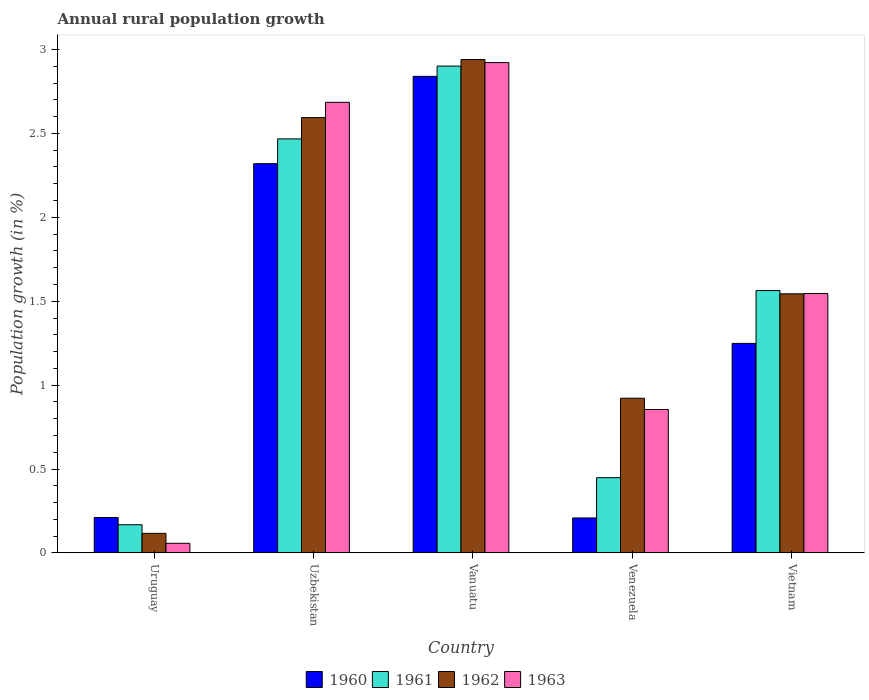How many different coloured bars are there?
Make the answer very short. 4. Are the number of bars per tick equal to the number of legend labels?
Provide a succinct answer. Yes. Are the number of bars on each tick of the X-axis equal?
Your answer should be compact. Yes. How many bars are there on the 3rd tick from the left?
Give a very brief answer. 4. How many bars are there on the 2nd tick from the right?
Your response must be concise. 4. What is the label of the 4th group of bars from the left?
Offer a very short reply. Venezuela. In how many cases, is the number of bars for a given country not equal to the number of legend labels?
Your answer should be very brief. 0. What is the percentage of rural population growth in 1962 in Uruguay?
Make the answer very short. 0.12. Across all countries, what is the maximum percentage of rural population growth in 1961?
Your response must be concise. 2.9. Across all countries, what is the minimum percentage of rural population growth in 1961?
Provide a succinct answer. 0.17. In which country was the percentage of rural population growth in 1961 maximum?
Your answer should be compact. Vanuatu. In which country was the percentage of rural population growth in 1963 minimum?
Your response must be concise. Uruguay. What is the total percentage of rural population growth in 1961 in the graph?
Ensure brevity in your answer.  7.55. What is the difference between the percentage of rural population growth in 1963 in Uruguay and that in Uzbekistan?
Provide a succinct answer. -2.63. What is the difference between the percentage of rural population growth in 1960 in Vanuatu and the percentage of rural population growth in 1963 in Uzbekistan?
Make the answer very short. 0.15. What is the average percentage of rural population growth in 1963 per country?
Offer a very short reply. 1.61. What is the difference between the percentage of rural population growth of/in 1962 and percentage of rural population growth of/in 1963 in Venezuela?
Provide a succinct answer. 0.07. In how many countries, is the percentage of rural population growth in 1962 greater than 1.6 %?
Keep it short and to the point. 2. What is the ratio of the percentage of rural population growth in 1962 in Venezuela to that in Vietnam?
Your answer should be compact. 0.6. What is the difference between the highest and the second highest percentage of rural population growth in 1961?
Make the answer very short. -1.34. What is the difference between the highest and the lowest percentage of rural population growth in 1963?
Provide a succinct answer. 2.86. In how many countries, is the percentage of rural population growth in 1963 greater than the average percentage of rural population growth in 1963 taken over all countries?
Your response must be concise. 2. Is the sum of the percentage of rural population growth in 1962 in Uruguay and Uzbekistan greater than the maximum percentage of rural population growth in 1961 across all countries?
Your answer should be compact. No. Is it the case that in every country, the sum of the percentage of rural population growth in 1961 and percentage of rural population growth in 1960 is greater than the sum of percentage of rural population growth in 1963 and percentage of rural population growth in 1962?
Offer a terse response. No. What does the 3rd bar from the left in Vanuatu represents?
Offer a terse response. 1962. What does the 2nd bar from the right in Vietnam represents?
Make the answer very short. 1962. Is it the case that in every country, the sum of the percentage of rural population growth in 1963 and percentage of rural population growth in 1962 is greater than the percentage of rural population growth in 1961?
Keep it short and to the point. Yes. How many countries are there in the graph?
Provide a short and direct response. 5. What is the difference between two consecutive major ticks on the Y-axis?
Keep it short and to the point. 0.5. Are the values on the major ticks of Y-axis written in scientific E-notation?
Ensure brevity in your answer.  No. How are the legend labels stacked?
Keep it short and to the point. Horizontal. What is the title of the graph?
Offer a terse response. Annual rural population growth. What is the label or title of the X-axis?
Your response must be concise. Country. What is the label or title of the Y-axis?
Give a very brief answer. Population growth (in %). What is the Population growth (in %) in 1960 in Uruguay?
Make the answer very short. 0.21. What is the Population growth (in %) in 1961 in Uruguay?
Give a very brief answer. 0.17. What is the Population growth (in %) of 1962 in Uruguay?
Make the answer very short. 0.12. What is the Population growth (in %) in 1963 in Uruguay?
Give a very brief answer. 0.06. What is the Population growth (in %) in 1960 in Uzbekistan?
Your response must be concise. 2.32. What is the Population growth (in %) of 1961 in Uzbekistan?
Ensure brevity in your answer.  2.47. What is the Population growth (in %) in 1962 in Uzbekistan?
Your response must be concise. 2.59. What is the Population growth (in %) in 1963 in Uzbekistan?
Your response must be concise. 2.69. What is the Population growth (in %) in 1960 in Vanuatu?
Your answer should be very brief. 2.84. What is the Population growth (in %) in 1961 in Vanuatu?
Give a very brief answer. 2.9. What is the Population growth (in %) in 1962 in Vanuatu?
Provide a short and direct response. 2.94. What is the Population growth (in %) of 1963 in Vanuatu?
Provide a short and direct response. 2.92. What is the Population growth (in %) in 1960 in Venezuela?
Give a very brief answer. 0.21. What is the Population growth (in %) in 1961 in Venezuela?
Give a very brief answer. 0.45. What is the Population growth (in %) of 1962 in Venezuela?
Provide a succinct answer. 0.92. What is the Population growth (in %) of 1963 in Venezuela?
Provide a short and direct response. 0.85. What is the Population growth (in %) of 1960 in Vietnam?
Your answer should be compact. 1.25. What is the Population growth (in %) in 1961 in Vietnam?
Give a very brief answer. 1.56. What is the Population growth (in %) in 1962 in Vietnam?
Provide a succinct answer. 1.54. What is the Population growth (in %) of 1963 in Vietnam?
Offer a very short reply. 1.55. Across all countries, what is the maximum Population growth (in %) of 1960?
Your answer should be very brief. 2.84. Across all countries, what is the maximum Population growth (in %) in 1961?
Offer a terse response. 2.9. Across all countries, what is the maximum Population growth (in %) of 1962?
Keep it short and to the point. 2.94. Across all countries, what is the maximum Population growth (in %) of 1963?
Keep it short and to the point. 2.92. Across all countries, what is the minimum Population growth (in %) in 1960?
Provide a succinct answer. 0.21. Across all countries, what is the minimum Population growth (in %) in 1961?
Offer a very short reply. 0.17. Across all countries, what is the minimum Population growth (in %) of 1962?
Give a very brief answer. 0.12. Across all countries, what is the minimum Population growth (in %) in 1963?
Give a very brief answer. 0.06. What is the total Population growth (in %) in 1960 in the graph?
Your answer should be compact. 6.83. What is the total Population growth (in %) in 1961 in the graph?
Provide a succinct answer. 7.55. What is the total Population growth (in %) in 1962 in the graph?
Make the answer very short. 8.12. What is the total Population growth (in %) in 1963 in the graph?
Give a very brief answer. 8.07. What is the difference between the Population growth (in %) in 1960 in Uruguay and that in Uzbekistan?
Make the answer very short. -2.11. What is the difference between the Population growth (in %) in 1961 in Uruguay and that in Uzbekistan?
Offer a very short reply. -2.3. What is the difference between the Population growth (in %) in 1962 in Uruguay and that in Uzbekistan?
Give a very brief answer. -2.48. What is the difference between the Population growth (in %) of 1963 in Uruguay and that in Uzbekistan?
Offer a terse response. -2.63. What is the difference between the Population growth (in %) of 1960 in Uruguay and that in Vanuatu?
Your answer should be very brief. -2.63. What is the difference between the Population growth (in %) of 1961 in Uruguay and that in Vanuatu?
Offer a terse response. -2.73. What is the difference between the Population growth (in %) in 1962 in Uruguay and that in Vanuatu?
Make the answer very short. -2.82. What is the difference between the Population growth (in %) in 1963 in Uruguay and that in Vanuatu?
Your response must be concise. -2.86. What is the difference between the Population growth (in %) in 1960 in Uruguay and that in Venezuela?
Offer a very short reply. 0. What is the difference between the Population growth (in %) in 1961 in Uruguay and that in Venezuela?
Offer a terse response. -0.28. What is the difference between the Population growth (in %) in 1962 in Uruguay and that in Venezuela?
Your answer should be compact. -0.81. What is the difference between the Population growth (in %) of 1963 in Uruguay and that in Venezuela?
Your answer should be very brief. -0.8. What is the difference between the Population growth (in %) in 1960 in Uruguay and that in Vietnam?
Provide a succinct answer. -1.04. What is the difference between the Population growth (in %) in 1961 in Uruguay and that in Vietnam?
Give a very brief answer. -1.4. What is the difference between the Population growth (in %) of 1962 in Uruguay and that in Vietnam?
Your response must be concise. -1.43. What is the difference between the Population growth (in %) of 1963 in Uruguay and that in Vietnam?
Ensure brevity in your answer.  -1.49. What is the difference between the Population growth (in %) of 1960 in Uzbekistan and that in Vanuatu?
Your response must be concise. -0.52. What is the difference between the Population growth (in %) of 1961 in Uzbekistan and that in Vanuatu?
Ensure brevity in your answer.  -0.43. What is the difference between the Population growth (in %) of 1962 in Uzbekistan and that in Vanuatu?
Give a very brief answer. -0.35. What is the difference between the Population growth (in %) of 1963 in Uzbekistan and that in Vanuatu?
Make the answer very short. -0.24. What is the difference between the Population growth (in %) in 1960 in Uzbekistan and that in Venezuela?
Your answer should be very brief. 2.11. What is the difference between the Population growth (in %) in 1961 in Uzbekistan and that in Venezuela?
Provide a succinct answer. 2.02. What is the difference between the Population growth (in %) in 1962 in Uzbekistan and that in Venezuela?
Offer a terse response. 1.67. What is the difference between the Population growth (in %) of 1963 in Uzbekistan and that in Venezuela?
Give a very brief answer. 1.83. What is the difference between the Population growth (in %) in 1960 in Uzbekistan and that in Vietnam?
Give a very brief answer. 1.07. What is the difference between the Population growth (in %) of 1961 in Uzbekistan and that in Vietnam?
Keep it short and to the point. 0.9. What is the difference between the Population growth (in %) of 1962 in Uzbekistan and that in Vietnam?
Give a very brief answer. 1.05. What is the difference between the Population growth (in %) in 1963 in Uzbekistan and that in Vietnam?
Give a very brief answer. 1.14. What is the difference between the Population growth (in %) in 1960 in Vanuatu and that in Venezuela?
Ensure brevity in your answer.  2.63. What is the difference between the Population growth (in %) of 1961 in Vanuatu and that in Venezuela?
Offer a terse response. 2.45. What is the difference between the Population growth (in %) of 1962 in Vanuatu and that in Venezuela?
Your answer should be compact. 2.02. What is the difference between the Population growth (in %) of 1963 in Vanuatu and that in Venezuela?
Make the answer very short. 2.07. What is the difference between the Population growth (in %) of 1960 in Vanuatu and that in Vietnam?
Provide a succinct answer. 1.59. What is the difference between the Population growth (in %) of 1961 in Vanuatu and that in Vietnam?
Keep it short and to the point. 1.34. What is the difference between the Population growth (in %) of 1962 in Vanuatu and that in Vietnam?
Your answer should be compact. 1.4. What is the difference between the Population growth (in %) in 1963 in Vanuatu and that in Vietnam?
Keep it short and to the point. 1.38. What is the difference between the Population growth (in %) in 1960 in Venezuela and that in Vietnam?
Provide a succinct answer. -1.04. What is the difference between the Population growth (in %) of 1961 in Venezuela and that in Vietnam?
Provide a succinct answer. -1.11. What is the difference between the Population growth (in %) in 1962 in Venezuela and that in Vietnam?
Keep it short and to the point. -0.62. What is the difference between the Population growth (in %) in 1963 in Venezuela and that in Vietnam?
Your answer should be very brief. -0.69. What is the difference between the Population growth (in %) of 1960 in Uruguay and the Population growth (in %) of 1961 in Uzbekistan?
Your response must be concise. -2.26. What is the difference between the Population growth (in %) in 1960 in Uruguay and the Population growth (in %) in 1962 in Uzbekistan?
Offer a very short reply. -2.38. What is the difference between the Population growth (in %) in 1960 in Uruguay and the Population growth (in %) in 1963 in Uzbekistan?
Offer a terse response. -2.47. What is the difference between the Population growth (in %) of 1961 in Uruguay and the Population growth (in %) of 1962 in Uzbekistan?
Provide a succinct answer. -2.43. What is the difference between the Population growth (in %) of 1961 in Uruguay and the Population growth (in %) of 1963 in Uzbekistan?
Provide a short and direct response. -2.52. What is the difference between the Population growth (in %) of 1962 in Uruguay and the Population growth (in %) of 1963 in Uzbekistan?
Your answer should be compact. -2.57. What is the difference between the Population growth (in %) in 1960 in Uruguay and the Population growth (in %) in 1961 in Vanuatu?
Provide a short and direct response. -2.69. What is the difference between the Population growth (in %) of 1960 in Uruguay and the Population growth (in %) of 1962 in Vanuatu?
Give a very brief answer. -2.73. What is the difference between the Population growth (in %) of 1960 in Uruguay and the Population growth (in %) of 1963 in Vanuatu?
Offer a terse response. -2.71. What is the difference between the Population growth (in %) in 1961 in Uruguay and the Population growth (in %) in 1962 in Vanuatu?
Offer a very short reply. -2.77. What is the difference between the Population growth (in %) of 1961 in Uruguay and the Population growth (in %) of 1963 in Vanuatu?
Ensure brevity in your answer.  -2.75. What is the difference between the Population growth (in %) of 1962 in Uruguay and the Population growth (in %) of 1963 in Vanuatu?
Offer a terse response. -2.8. What is the difference between the Population growth (in %) in 1960 in Uruguay and the Population growth (in %) in 1961 in Venezuela?
Provide a succinct answer. -0.24. What is the difference between the Population growth (in %) of 1960 in Uruguay and the Population growth (in %) of 1962 in Venezuela?
Provide a short and direct response. -0.71. What is the difference between the Population growth (in %) in 1960 in Uruguay and the Population growth (in %) in 1963 in Venezuela?
Keep it short and to the point. -0.64. What is the difference between the Population growth (in %) of 1961 in Uruguay and the Population growth (in %) of 1962 in Venezuela?
Provide a short and direct response. -0.75. What is the difference between the Population growth (in %) in 1961 in Uruguay and the Population growth (in %) in 1963 in Venezuela?
Provide a succinct answer. -0.69. What is the difference between the Population growth (in %) in 1962 in Uruguay and the Population growth (in %) in 1963 in Venezuela?
Keep it short and to the point. -0.74. What is the difference between the Population growth (in %) of 1960 in Uruguay and the Population growth (in %) of 1961 in Vietnam?
Your answer should be compact. -1.35. What is the difference between the Population growth (in %) in 1960 in Uruguay and the Population growth (in %) in 1962 in Vietnam?
Your response must be concise. -1.33. What is the difference between the Population growth (in %) of 1960 in Uruguay and the Population growth (in %) of 1963 in Vietnam?
Make the answer very short. -1.33. What is the difference between the Population growth (in %) of 1961 in Uruguay and the Population growth (in %) of 1962 in Vietnam?
Your response must be concise. -1.38. What is the difference between the Population growth (in %) of 1961 in Uruguay and the Population growth (in %) of 1963 in Vietnam?
Provide a succinct answer. -1.38. What is the difference between the Population growth (in %) in 1962 in Uruguay and the Population growth (in %) in 1963 in Vietnam?
Your response must be concise. -1.43. What is the difference between the Population growth (in %) of 1960 in Uzbekistan and the Population growth (in %) of 1961 in Vanuatu?
Keep it short and to the point. -0.58. What is the difference between the Population growth (in %) of 1960 in Uzbekistan and the Population growth (in %) of 1962 in Vanuatu?
Provide a succinct answer. -0.62. What is the difference between the Population growth (in %) in 1960 in Uzbekistan and the Population growth (in %) in 1963 in Vanuatu?
Your answer should be very brief. -0.6. What is the difference between the Population growth (in %) in 1961 in Uzbekistan and the Population growth (in %) in 1962 in Vanuatu?
Keep it short and to the point. -0.47. What is the difference between the Population growth (in %) of 1961 in Uzbekistan and the Population growth (in %) of 1963 in Vanuatu?
Ensure brevity in your answer.  -0.45. What is the difference between the Population growth (in %) in 1962 in Uzbekistan and the Population growth (in %) in 1963 in Vanuatu?
Give a very brief answer. -0.33. What is the difference between the Population growth (in %) in 1960 in Uzbekistan and the Population growth (in %) in 1961 in Venezuela?
Keep it short and to the point. 1.87. What is the difference between the Population growth (in %) in 1960 in Uzbekistan and the Population growth (in %) in 1962 in Venezuela?
Give a very brief answer. 1.4. What is the difference between the Population growth (in %) of 1960 in Uzbekistan and the Population growth (in %) of 1963 in Venezuela?
Give a very brief answer. 1.46. What is the difference between the Population growth (in %) of 1961 in Uzbekistan and the Population growth (in %) of 1962 in Venezuela?
Your answer should be very brief. 1.55. What is the difference between the Population growth (in %) of 1961 in Uzbekistan and the Population growth (in %) of 1963 in Venezuela?
Give a very brief answer. 1.61. What is the difference between the Population growth (in %) of 1962 in Uzbekistan and the Population growth (in %) of 1963 in Venezuela?
Offer a terse response. 1.74. What is the difference between the Population growth (in %) in 1960 in Uzbekistan and the Population growth (in %) in 1961 in Vietnam?
Ensure brevity in your answer.  0.76. What is the difference between the Population growth (in %) in 1960 in Uzbekistan and the Population growth (in %) in 1962 in Vietnam?
Keep it short and to the point. 0.78. What is the difference between the Population growth (in %) in 1960 in Uzbekistan and the Population growth (in %) in 1963 in Vietnam?
Offer a very short reply. 0.77. What is the difference between the Population growth (in %) in 1961 in Uzbekistan and the Population growth (in %) in 1962 in Vietnam?
Ensure brevity in your answer.  0.92. What is the difference between the Population growth (in %) of 1961 in Uzbekistan and the Population growth (in %) of 1963 in Vietnam?
Provide a succinct answer. 0.92. What is the difference between the Population growth (in %) in 1962 in Uzbekistan and the Population growth (in %) in 1963 in Vietnam?
Offer a terse response. 1.05. What is the difference between the Population growth (in %) of 1960 in Vanuatu and the Population growth (in %) of 1961 in Venezuela?
Make the answer very short. 2.39. What is the difference between the Population growth (in %) in 1960 in Vanuatu and the Population growth (in %) in 1962 in Venezuela?
Provide a succinct answer. 1.92. What is the difference between the Population growth (in %) of 1960 in Vanuatu and the Population growth (in %) of 1963 in Venezuela?
Ensure brevity in your answer.  1.99. What is the difference between the Population growth (in %) in 1961 in Vanuatu and the Population growth (in %) in 1962 in Venezuela?
Your response must be concise. 1.98. What is the difference between the Population growth (in %) in 1961 in Vanuatu and the Population growth (in %) in 1963 in Venezuela?
Your answer should be compact. 2.05. What is the difference between the Population growth (in %) of 1962 in Vanuatu and the Population growth (in %) of 1963 in Venezuela?
Offer a terse response. 2.09. What is the difference between the Population growth (in %) of 1960 in Vanuatu and the Population growth (in %) of 1961 in Vietnam?
Provide a short and direct response. 1.28. What is the difference between the Population growth (in %) of 1960 in Vanuatu and the Population growth (in %) of 1962 in Vietnam?
Provide a short and direct response. 1.3. What is the difference between the Population growth (in %) in 1960 in Vanuatu and the Population growth (in %) in 1963 in Vietnam?
Your answer should be very brief. 1.29. What is the difference between the Population growth (in %) of 1961 in Vanuatu and the Population growth (in %) of 1962 in Vietnam?
Provide a succinct answer. 1.36. What is the difference between the Population growth (in %) of 1961 in Vanuatu and the Population growth (in %) of 1963 in Vietnam?
Make the answer very short. 1.35. What is the difference between the Population growth (in %) in 1962 in Vanuatu and the Population growth (in %) in 1963 in Vietnam?
Provide a short and direct response. 1.39. What is the difference between the Population growth (in %) of 1960 in Venezuela and the Population growth (in %) of 1961 in Vietnam?
Keep it short and to the point. -1.35. What is the difference between the Population growth (in %) of 1960 in Venezuela and the Population growth (in %) of 1962 in Vietnam?
Offer a very short reply. -1.34. What is the difference between the Population growth (in %) in 1960 in Venezuela and the Population growth (in %) in 1963 in Vietnam?
Offer a very short reply. -1.34. What is the difference between the Population growth (in %) in 1961 in Venezuela and the Population growth (in %) in 1962 in Vietnam?
Keep it short and to the point. -1.1. What is the difference between the Population growth (in %) in 1961 in Venezuela and the Population growth (in %) in 1963 in Vietnam?
Your response must be concise. -1.1. What is the difference between the Population growth (in %) in 1962 in Venezuela and the Population growth (in %) in 1963 in Vietnam?
Your response must be concise. -0.62. What is the average Population growth (in %) in 1960 per country?
Your answer should be compact. 1.37. What is the average Population growth (in %) in 1961 per country?
Give a very brief answer. 1.51. What is the average Population growth (in %) of 1962 per country?
Make the answer very short. 1.62. What is the average Population growth (in %) of 1963 per country?
Offer a terse response. 1.61. What is the difference between the Population growth (in %) of 1960 and Population growth (in %) of 1961 in Uruguay?
Offer a very short reply. 0.04. What is the difference between the Population growth (in %) in 1960 and Population growth (in %) in 1962 in Uruguay?
Your response must be concise. 0.09. What is the difference between the Population growth (in %) in 1960 and Population growth (in %) in 1963 in Uruguay?
Keep it short and to the point. 0.15. What is the difference between the Population growth (in %) of 1961 and Population growth (in %) of 1962 in Uruguay?
Your response must be concise. 0.05. What is the difference between the Population growth (in %) of 1961 and Population growth (in %) of 1963 in Uruguay?
Offer a very short reply. 0.11. What is the difference between the Population growth (in %) of 1962 and Population growth (in %) of 1963 in Uruguay?
Provide a succinct answer. 0.06. What is the difference between the Population growth (in %) of 1960 and Population growth (in %) of 1961 in Uzbekistan?
Your response must be concise. -0.15. What is the difference between the Population growth (in %) of 1960 and Population growth (in %) of 1962 in Uzbekistan?
Offer a terse response. -0.27. What is the difference between the Population growth (in %) in 1960 and Population growth (in %) in 1963 in Uzbekistan?
Offer a terse response. -0.37. What is the difference between the Population growth (in %) of 1961 and Population growth (in %) of 1962 in Uzbekistan?
Your answer should be very brief. -0.13. What is the difference between the Population growth (in %) in 1961 and Population growth (in %) in 1963 in Uzbekistan?
Your response must be concise. -0.22. What is the difference between the Population growth (in %) in 1962 and Population growth (in %) in 1963 in Uzbekistan?
Your response must be concise. -0.09. What is the difference between the Population growth (in %) in 1960 and Population growth (in %) in 1961 in Vanuatu?
Make the answer very short. -0.06. What is the difference between the Population growth (in %) in 1960 and Population growth (in %) in 1962 in Vanuatu?
Your answer should be compact. -0.1. What is the difference between the Population growth (in %) of 1960 and Population growth (in %) of 1963 in Vanuatu?
Offer a terse response. -0.08. What is the difference between the Population growth (in %) in 1961 and Population growth (in %) in 1962 in Vanuatu?
Ensure brevity in your answer.  -0.04. What is the difference between the Population growth (in %) of 1961 and Population growth (in %) of 1963 in Vanuatu?
Offer a very short reply. -0.02. What is the difference between the Population growth (in %) in 1962 and Population growth (in %) in 1963 in Vanuatu?
Provide a short and direct response. 0.02. What is the difference between the Population growth (in %) of 1960 and Population growth (in %) of 1961 in Venezuela?
Ensure brevity in your answer.  -0.24. What is the difference between the Population growth (in %) in 1960 and Population growth (in %) in 1962 in Venezuela?
Provide a short and direct response. -0.71. What is the difference between the Population growth (in %) of 1960 and Population growth (in %) of 1963 in Venezuela?
Provide a short and direct response. -0.65. What is the difference between the Population growth (in %) in 1961 and Population growth (in %) in 1962 in Venezuela?
Keep it short and to the point. -0.47. What is the difference between the Population growth (in %) in 1961 and Population growth (in %) in 1963 in Venezuela?
Provide a short and direct response. -0.41. What is the difference between the Population growth (in %) in 1962 and Population growth (in %) in 1963 in Venezuela?
Ensure brevity in your answer.  0.07. What is the difference between the Population growth (in %) in 1960 and Population growth (in %) in 1961 in Vietnam?
Your answer should be very brief. -0.31. What is the difference between the Population growth (in %) in 1960 and Population growth (in %) in 1962 in Vietnam?
Give a very brief answer. -0.3. What is the difference between the Population growth (in %) of 1960 and Population growth (in %) of 1963 in Vietnam?
Ensure brevity in your answer.  -0.3. What is the difference between the Population growth (in %) of 1961 and Population growth (in %) of 1962 in Vietnam?
Ensure brevity in your answer.  0.02. What is the difference between the Population growth (in %) in 1961 and Population growth (in %) in 1963 in Vietnam?
Your response must be concise. 0.02. What is the difference between the Population growth (in %) in 1962 and Population growth (in %) in 1963 in Vietnam?
Offer a very short reply. -0. What is the ratio of the Population growth (in %) of 1960 in Uruguay to that in Uzbekistan?
Provide a succinct answer. 0.09. What is the ratio of the Population growth (in %) in 1961 in Uruguay to that in Uzbekistan?
Offer a very short reply. 0.07. What is the ratio of the Population growth (in %) of 1962 in Uruguay to that in Uzbekistan?
Your answer should be very brief. 0.05. What is the ratio of the Population growth (in %) of 1963 in Uruguay to that in Uzbekistan?
Offer a terse response. 0.02. What is the ratio of the Population growth (in %) of 1960 in Uruguay to that in Vanuatu?
Your answer should be compact. 0.07. What is the ratio of the Population growth (in %) in 1961 in Uruguay to that in Vanuatu?
Provide a short and direct response. 0.06. What is the ratio of the Population growth (in %) of 1962 in Uruguay to that in Vanuatu?
Your response must be concise. 0.04. What is the ratio of the Population growth (in %) in 1963 in Uruguay to that in Vanuatu?
Your answer should be compact. 0.02. What is the ratio of the Population growth (in %) in 1960 in Uruguay to that in Venezuela?
Provide a succinct answer. 1.01. What is the ratio of the Population growth (in %) in 1961 in Uruguay to that in Venezuela?
Provide a short and direct response. 0.37. What is the ratio of the Population growth (in %) in 1962 in Uruguay to that in Venezuela?
Your response must be concise. 0.13. What is the ratio of the Population growth (in %) in 1963 in Uruguay to that in Venezuela?
Your answer should be very brief. 0.07. What is the ratio of the Population growth (in %) of 1960 in Uruguay to that in Vietnam?
Ensure brevity in your answer.  0.17. What is the ratio of the Population growth (in %) in 1961 in Uruguay to that in Vietnam?
Make the answer very short. 0.11. What is the ratio of the Population growth (in %) in 1962 in Uruguay to that in Vietnam?
Offer a very short reply. 0.08. What is the ratio of the Population growth (in %) of 1963 in Uruguay to that in Vietnam?
Offer a terse response. 0.04. What is the ratio of the Population growth (in %) in 1960 in Uzbekistan to that in Vanuatu?
Provide a succinct answer. 0.82. What is the ratio of the Population growth (in %) of 1961 in Uzbekistan to that in Vanuatu?
Your answer should be compact. 0.85. What is the ratio of the Population growth (in %) of 1962 in Uzbekistan to that in Vanuatu?
Offer a very short reply. 0.88. What is the ratio of the Population growth (in %) in 1963 in Uzbekistan to that in Vanuatu?
Give a very brief answer. 0.92. What is the ratio of the Population growth (in %) of 1960 in Uzbekistan to that in Venezuela?
Give a very brief answer. 11.11. What is the ratio of the Population growth (in %) of 1961 in Uzbekistan to that in Venezuela?
Your response must be concise. 5.5. What is the ratio of the Population growth (in %) in 1962 in Uzbekistan to that in Venezuela?
Give a very brief answer. 2.81. What is the ratio of the Population growth (in %) in 1963 in Uzbekistan to that in Venezuela?
Offer a very short reply. 3.14. What is the ratio of the Population growth (in %) of 1960 in Uzbekistan to that in Vietnam?
Ensure brevity in your answer.  1.86. What is the ratio of the Population growth (in %) in 1961 in Uzbekistan to that in Vietnam?
Keep it short and to the point. 1.58. What is the ratio of the Population growth (in %) of 1962 in Uzbekistan to that in Vietnam?
Make the answer very short. 1.68. What is the ratio of the Population growth (in %) in 1963 in Uzbekistan to that in Vietnam?
Your answer should be compact. 1.74. What is the ratio of the Population growth (in %) in 1960 in Vanuatu to that in Venezuela?
Provide a short and direct response. 13.61. What is the ratio of the Population growth (in %) in 1961 in Vanuatu to that in Venezuela?
Provide a short and direct response. 6.46. What is the ratio of the Population growth (in %) in 1962 in Vanuatu to that in Venezuela?
Give a very brief answer. 3.19. What is the ratio of the Population growth (in %) of 1963 in Vanuatu to that in Venezuela?
Keep it short and to the point. 3.42. What is the ratio of the Population growth (in %) of 1960 in Vanuatu to that in Vietnam?
Make the answer very short. 2.27. What is the ratio of the Population growth (in %) in 1961 in Vanuatu to that in Vietnam?
Your answer should be very brief. 1.86. What is the ratio of the Population growth (in %) of 1962 in Vanuatu to that in Vietnam?
Make the answer very short. 1.9. What is the ratio of the Population growth (in %) in 1963 in Vanuatu to that in Vietnam?
Give a very brief answer. 1.89. What is the ratio of the Population growth (in %) in 1960 in Venezuela to that in Vietnam?
Keep it short and to the point. 0.17. What is the ratio of the Population growth (in %) in 1961 in Venezuela to that in Vietnam?
Your answer should be compact. 0.29. What is the ratio of the Population growth (in %) in 1962 in Venezuela to that in Vietnam?
Provide a short and direct response. 0.6. What is the ratio of the Population growth (in %) in 1963 in Venezuela to that in Vietnam?
Your answer should be very brief. 0.55. What is the difference between the highest and the second highest Population growth (in %) of 1960?
Your response must be concise. 0.52. What is the difference between the highest and the second highest Population growth (in %) of 1961?
Your answer should be compact. 0.43. What is the difference between the highest and the second highest Population growth (in %) of 1962?
Ensure brevity in your answer.  0.35. What is the difference between the highest and the second highest Population growth (in %) of 1963?
Make the answer very short. 0.24. What is the difference between the highest and the lowest Population growth (in %) of 1960?
Your answer should be very brief. 2.63. What is the difference between the highest and the lowest Population growth (in %) in 1961?
Provide a short and direct response. 2.73. What is the difference between the highest and the lowest Population growth (in %) in 1962?
Ensure brevity in your answer.  2.82. What is the difference between the highest and the lowest Population growth (in %) of 1963?
Your answer should be compact. 2.86. 